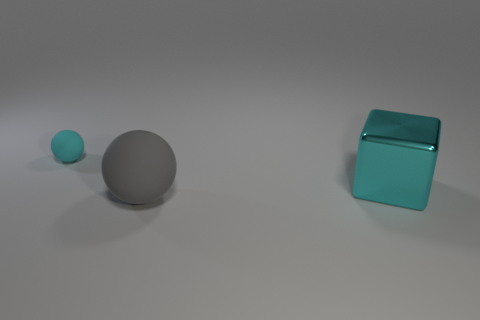Can you describe the colors and shapes of the objects in the image? In the image, there are three objects: a small teal ball, a medium-sized grey sphere, and a large teal cube. All objects have a smooth surface and distinct, solid colors. 